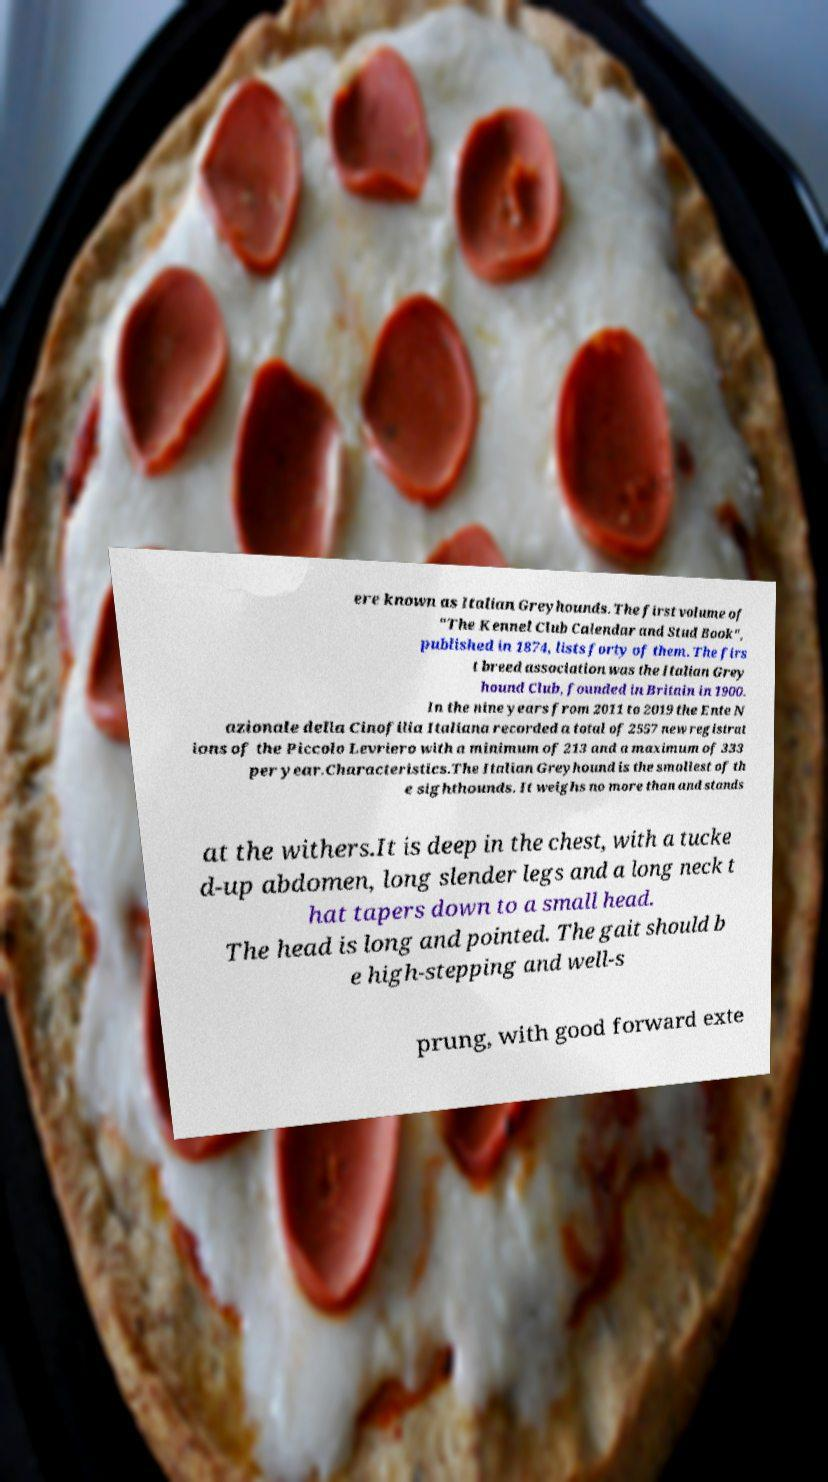For documentation purposes, I need the text within this image transcribed. Could you provide that? ere known as Italian Greyhounds. The first volume of "The Kennel Club Calendar and Stud Book", published in 1874, lists forty of them. The firs t breed association was the Italian Grey hound Club, founded in Britain in 1900. In the nine years from 2011 to 2019 the Ente N azionale della Cinofilia Italiana recorded a total of 2557 new registrat ions of the Piccolo Levriero with a minimum of 213 and a maximum of 333 per year.Characteristics.The Italian Greyhound is the smallest of th e sighthounds. It weighs no more than and stands at the withers.It is deep in the chest, with a tucke d-up abdomen, long slender legs and a long neck t hat tapers down to a small head. The head is long and pointed. The gait should b e high-stepping and well-s prung, with good forward exte 